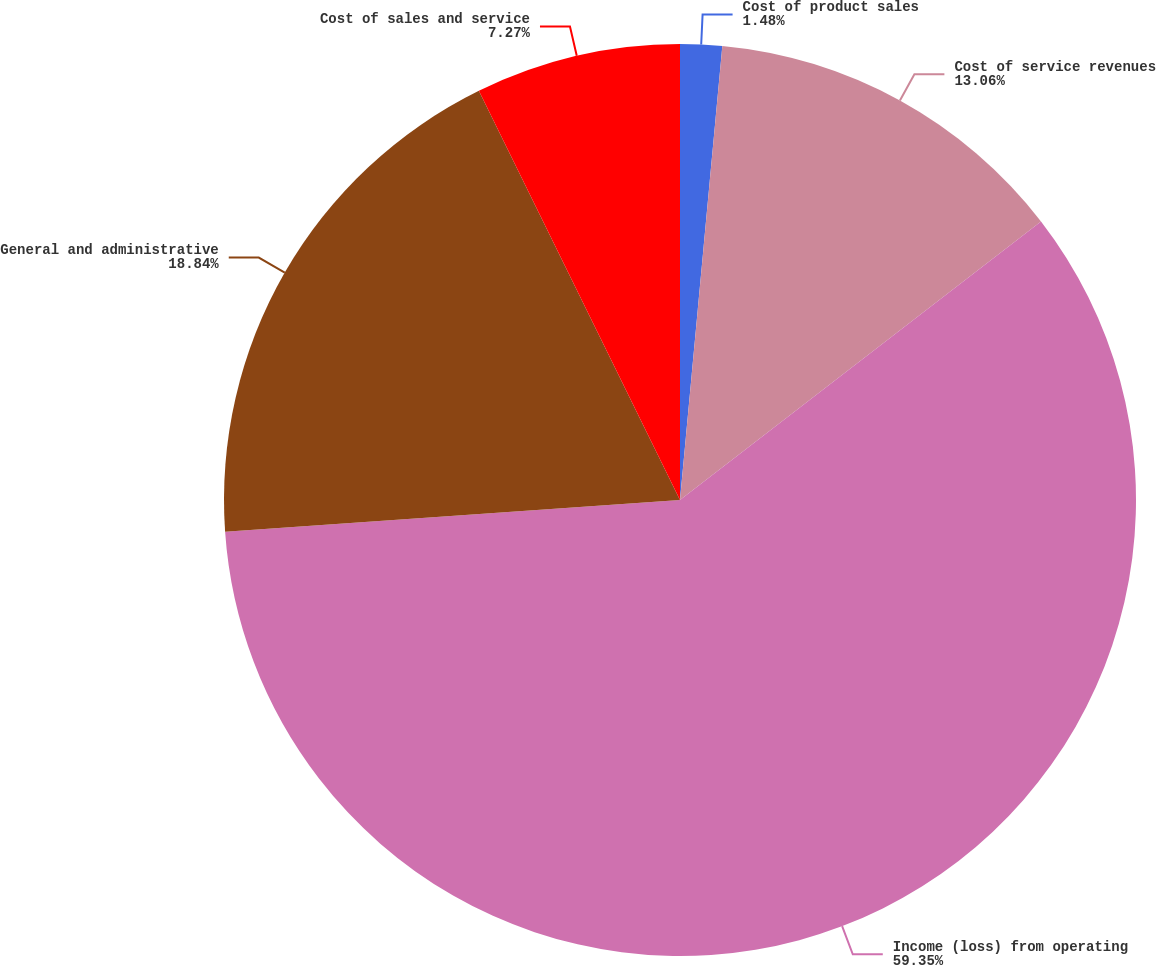Convert chart. <chart><loc_0><loc_0><loc_500><loc_500><pie_chart><fcel>Cost of product sales<fcel>Cost of service revenues<fcel>Income (loss) from operating<fcel>General and administrative<fcel>Cost of sales and service<nl><fcel>1.48%<fcel>13.06%<fcel>59.35%<fcel>18.84%<fcel>7.27%<nl></chart> 